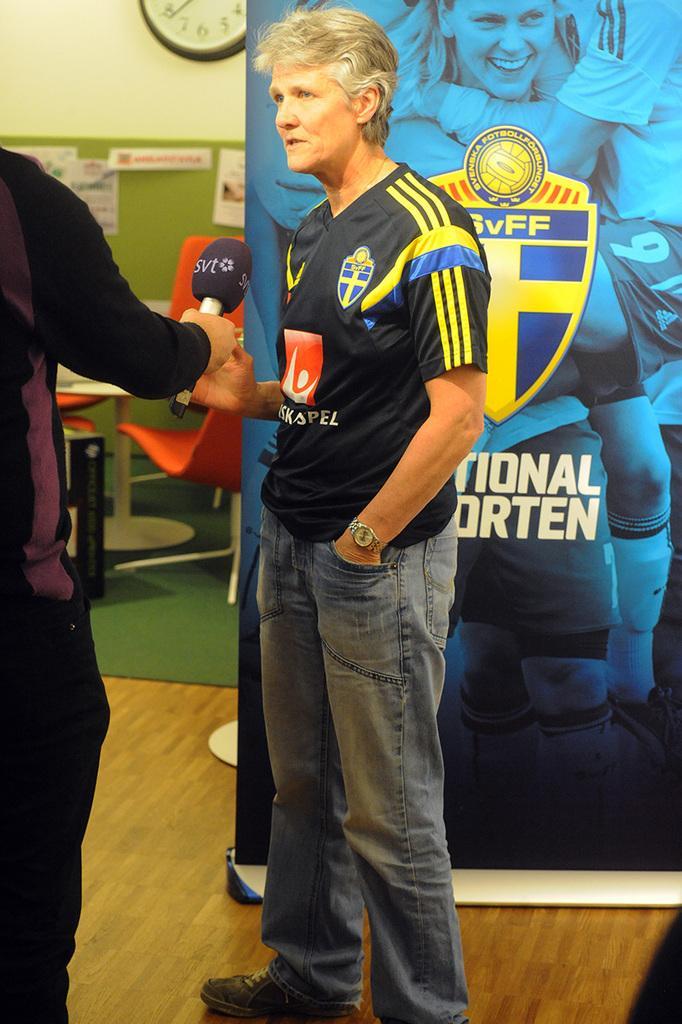Describe this image in one or two sentences. This image consists of two men standing and talking. At the bottom, there is a floor. In the background, there is a floor. To the left, there is a wall on which a clock is fixed. 